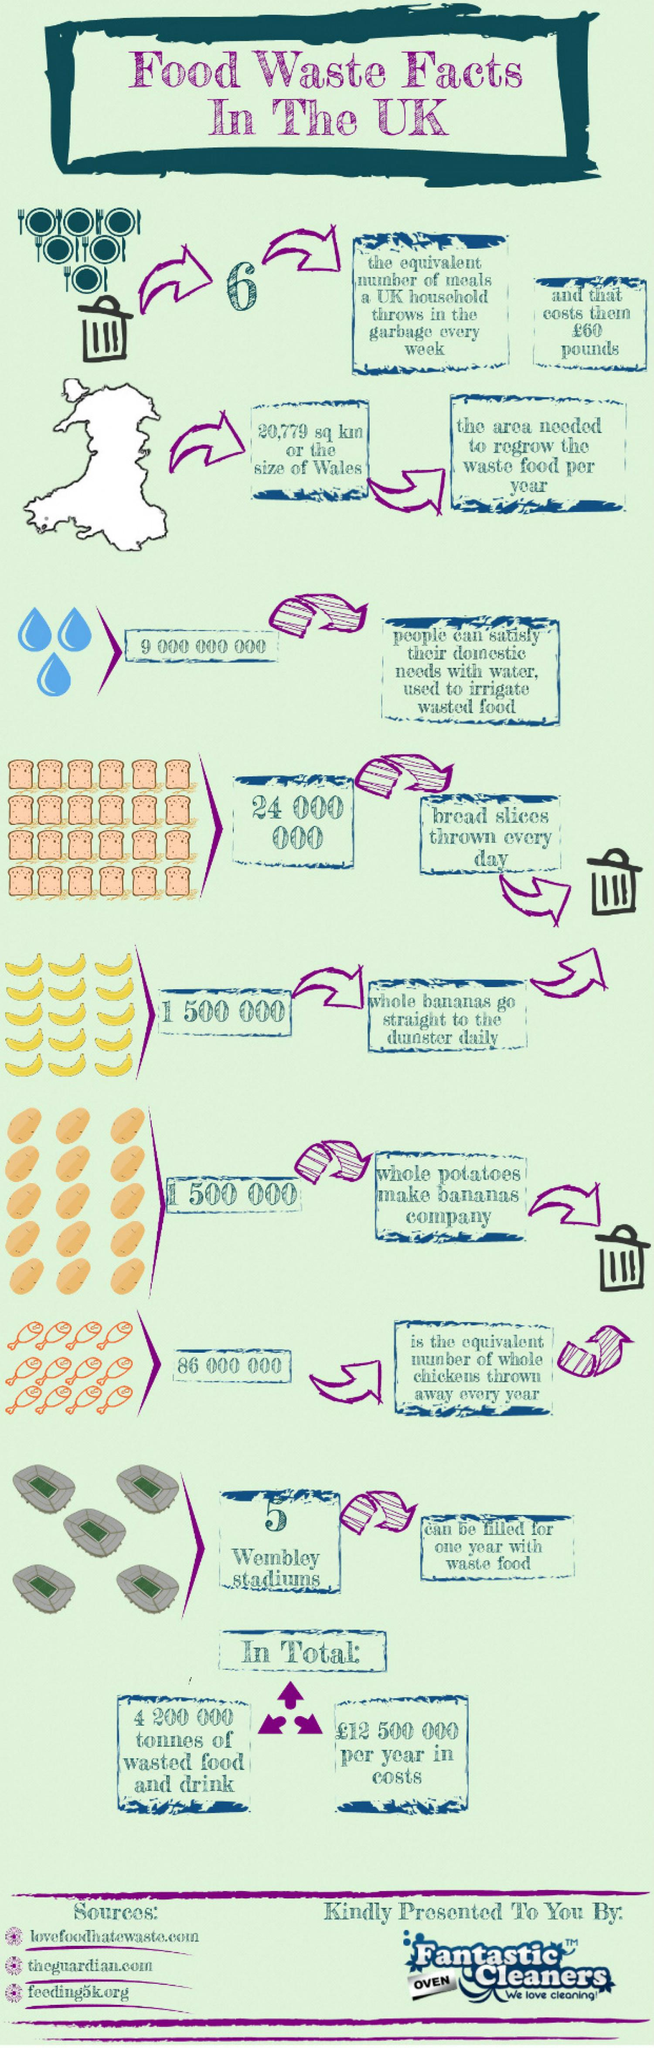Give some essential details in this illustration. The UK throws away an estimated 24 million bread slices every day. 